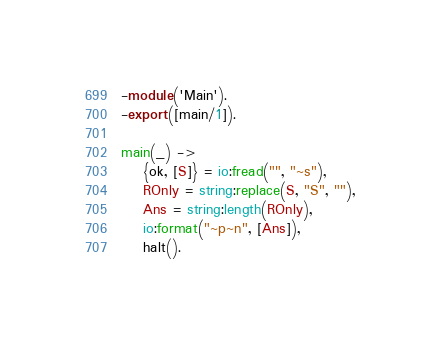Convert code to text. <code><loc_0><loc_0><loc_500><loc_500><_Erlang_>-module('Main').
-export([main/1]).

main(_) ->
    {ok, [S]} = io:fread("", "~s"),
    ROnly = string:replace(S, "S", ""),
    Ans = string:length(ROnly),
    io:format("~p~n", [Ans]),
    halt().</code> 